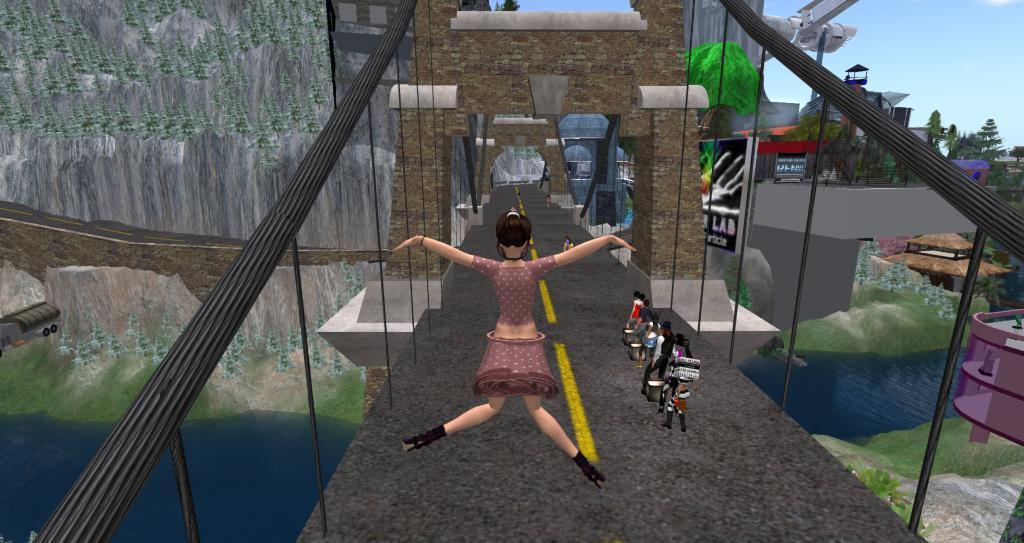Could you give a brief overview of what you see in this image? In this image I can see few people are holding something and walking on the bridge. I can see a rock,trees,water,vehicle,road,houses and boards. The sky is in blue color. It is an animated image. 